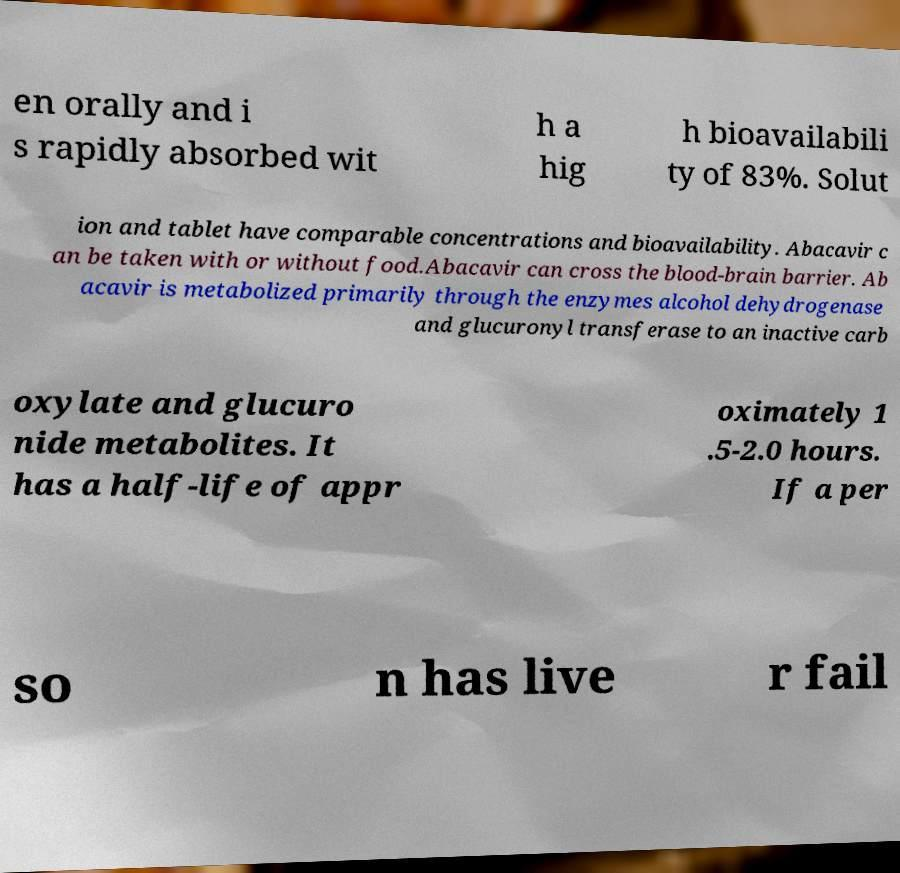For documentation purposes, I need the text within this image transcribed. Could you provide that? en orally and i s rapidly absorbed wit h a hig h bioavailabili ty of 83%. Solut ion and tablet have comparable concentrations and bioavailability. Abacavir c an be taken with or without food.Abacavir can cross the blood-brain barrier. Ab acavir is metabolized primarily through the enzymes alcohol dehydrogenase and glucuronyl transferase to an inactive carb oxylate and glucuro nide metabolites. It has a half-life of appr oximately 1 .5-2.0 hours. If a per so n has live r fail 